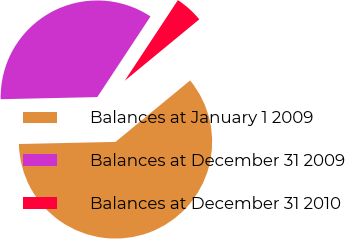Convert chart. <chart><loc_0><loc_0><loc_500><loc_500><pie_chart><fcel>Balances at January 1 2009<fcel>Balances at December 31 2009<fcel>Balances at December 31 2010<nl><fcel>60.62%<fcel>34.63%<fcel>4.75%<nl></chart> 